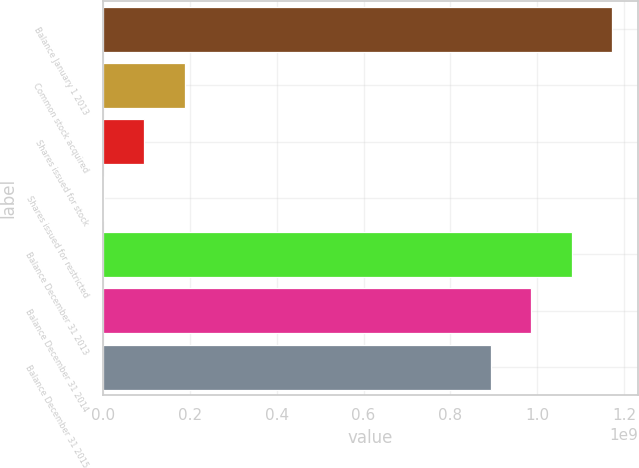Convert chart. <chart><loc_0><loc_0><loc_500><loc_500><bar_chart><fcel>Balance January 1 2013<fcel>Common stock acquired<fcel>Shares issued for stock<fcel>Shares issued for restricted<fcel>Balance December 31 2013<fcel>Balance December 31 2014<fcel>Balance December 31 2015<nl><fcel>1.17288e+09<fcel>1.88672e+08<fcel>9.52895e+07<fcel>1.90738e+06<fcel>1.0795e+09<fcel>9.86121e+08<fcel>8.92739e+08<nl></chart> 